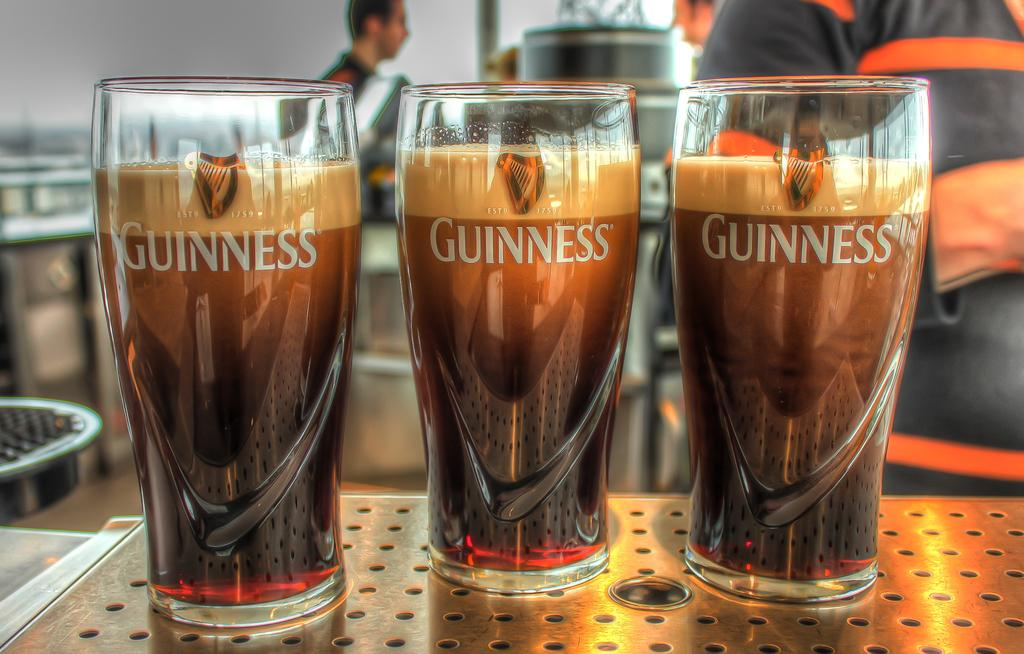<image>
Provide a brief description of the given image. 3 pints of guinness beer sit on the bar 